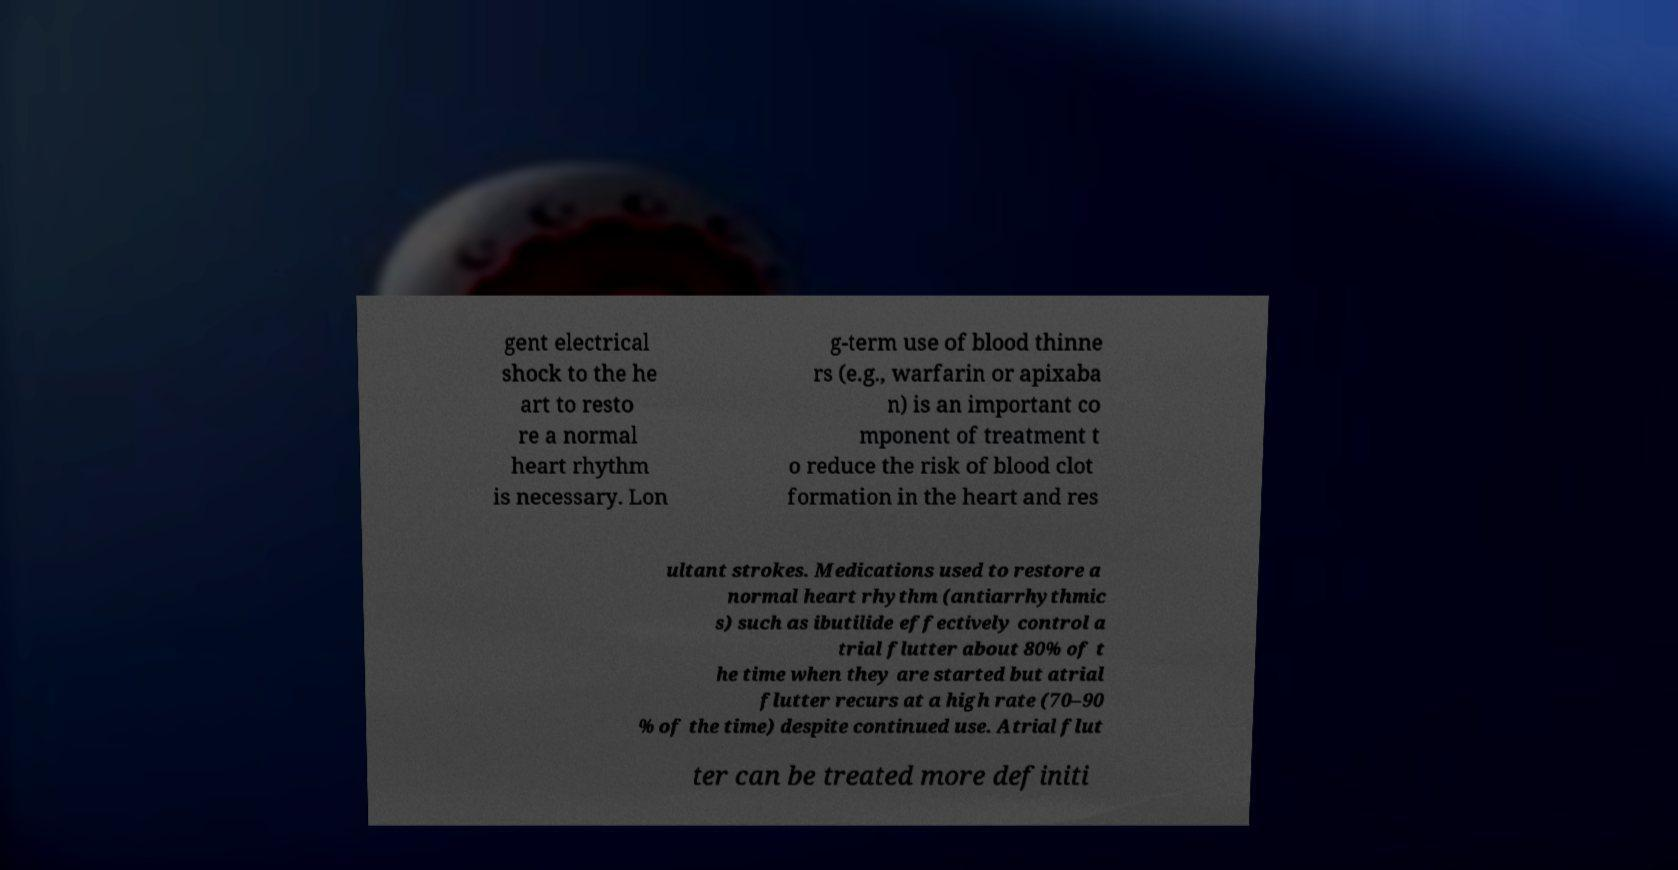What messages or text are displayed in this image? I need them in a readable, typed format. gent electrical shock to the he art to resto re a normal heart rhythm is necessary. Lon g-term use of blood thinne rs (e.g., warfarin or apixaba n) is an important co mponent of treatment t o reduce the risk of blood clot formation in the heart and res ultant strokes. Medications used to restore a normal heart rhythm (antiarrhythmic s) such as ibutilide effectively control a trial flutter about 80% of t he time when they are started but atrial flutter recurs at a high rate (70–90 % of the time) despite continued use. Atrial flut ter can be treated more definiti 